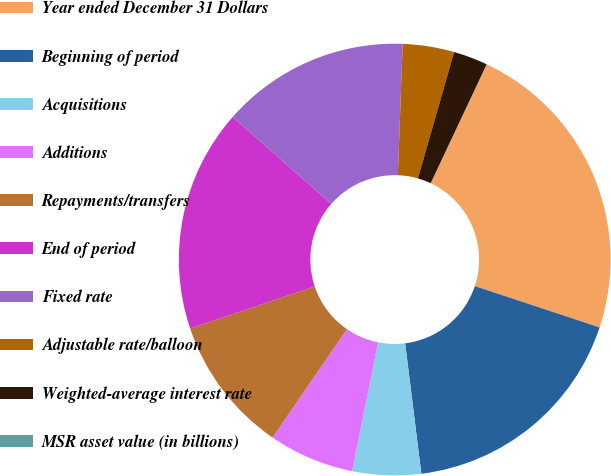Convert chart. <chart><loc_0><loc_0><loc_500><loc_500><pie_chart><fcel>Year ended December 31 Dollars<fcel>Beginning of period<fcel>Acquisitions<fcel>Additions<fcel>Repayments/transfers<fcel>End of period<fcel>Fixed rate<fcel>Adjustable rate/balloon<fcel>Weighted-average interest rate<fcel>MSR asset value (in billions)<nl><fcel>23.07%<fcel>17.94%<fcel>5.13%<fcel>6.41%<fcel>10.26%<fcel>16.66%<fcel>14.1%<fcel>3.85%<fcel>2.57%<fcel>0.01%<nl></chart> 